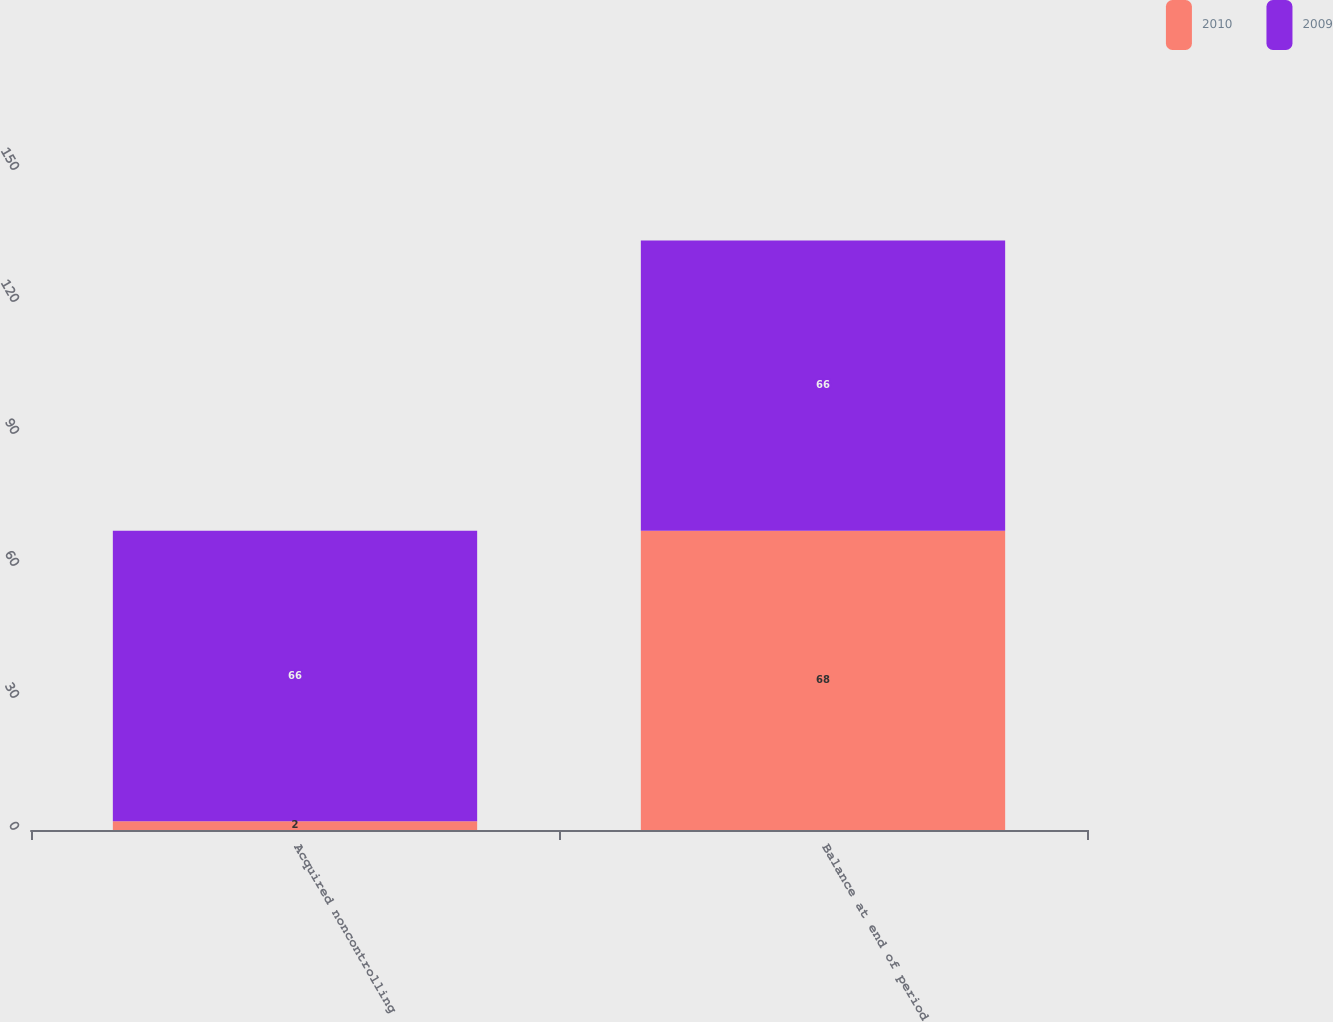<chart> <loc_0><loc_0><loc_500><loc_500><stacked_bar_chart><ecel><fcel>Acquired noncontrolling<fcel>Balance at end of period<nl><fcel>2010<fcel>2<fcel>68<nl><fcel>2009<fcel>66<fcel>66<nl></chart> 